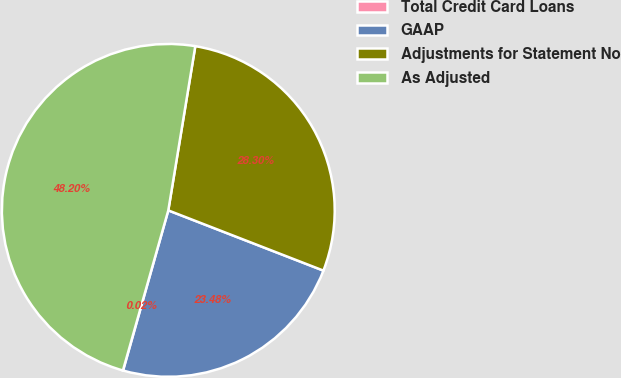Convert chart to OTSL. <chart><loc_0><loc_0><loc_500><loc_500><pie_chart><fcel>Total Credit Card Loans<fcel>GAAP<fcel>Adjustments for Statement No<fcel>As Adjusted<nl><fcel>0.02%<fcel>23.48%<fcel>28.3%<fcel>48.2%<nl></chart> 